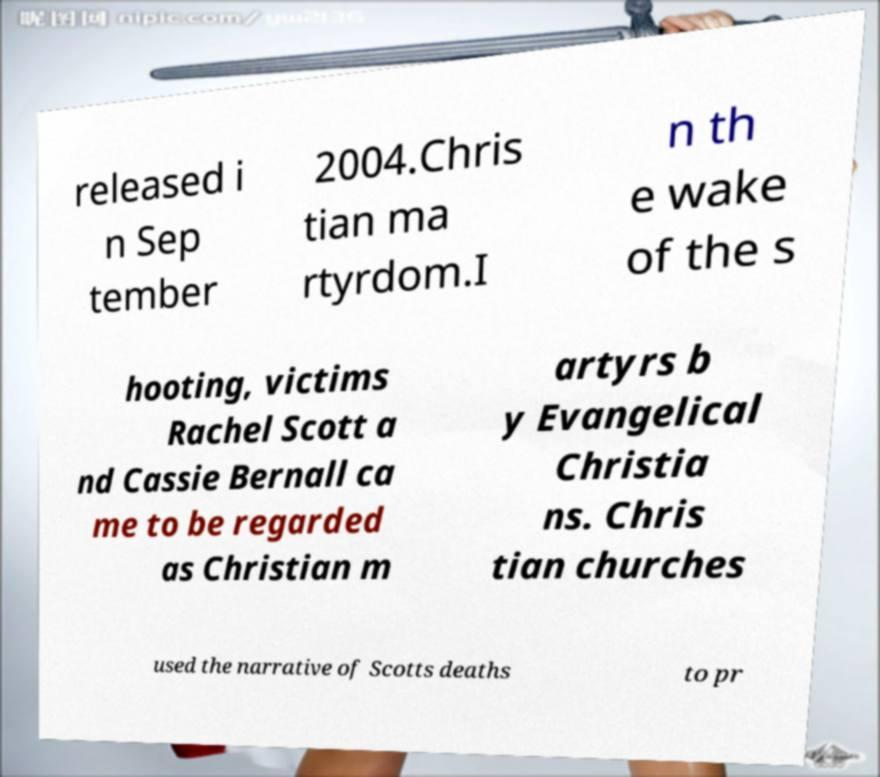I need the written content from this picture converted into text. Can you do that? released i n Sep tember 2004.Chris tian ma rtyrdom.I n th e wake of the s hooting, victims Rachel Scott a nd Cassie Bernall ca me to be regarded as Christian m artyrs b y Evangelical Christia ns. Chris tian churches used the narrative of Scotts deaths to pr 